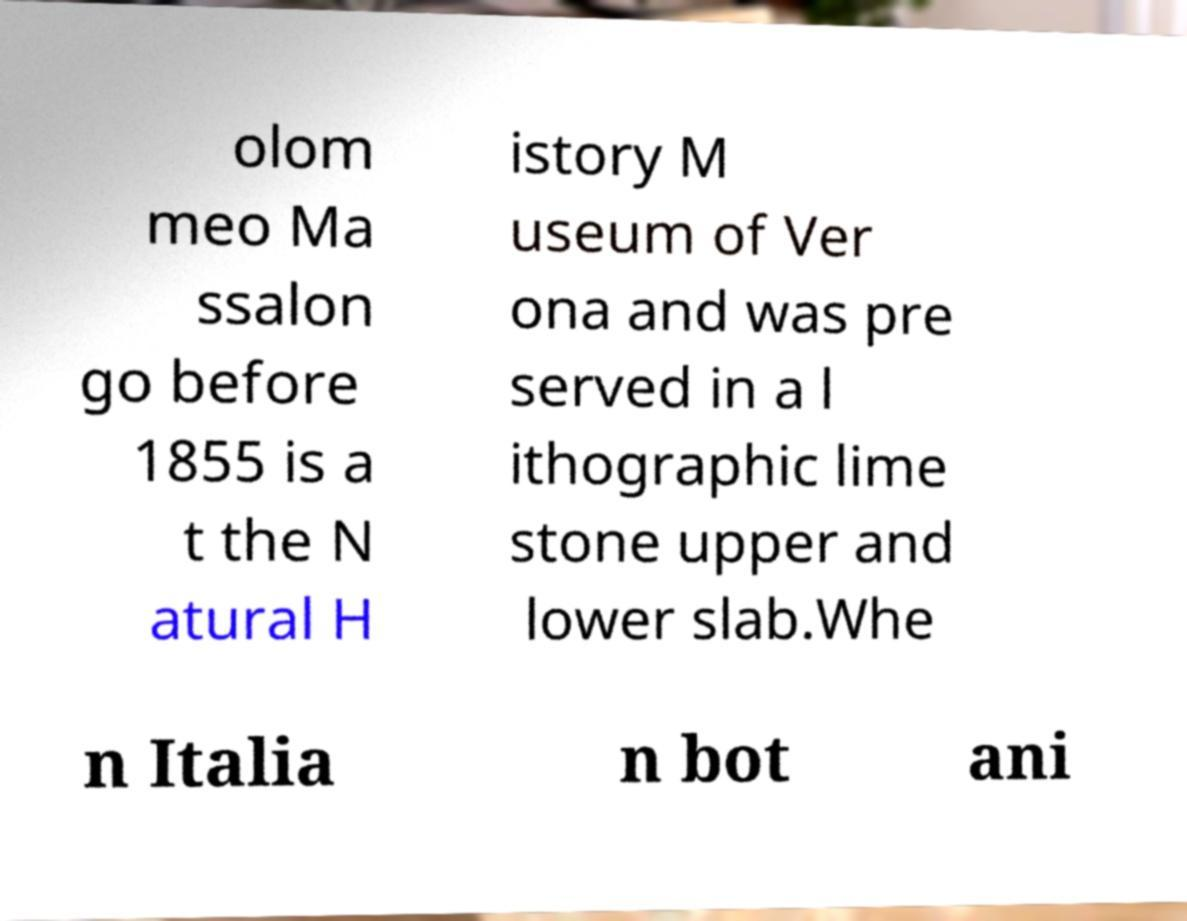Could you extract and type out the text from this image? olom meo Ma ssalon go before 1855 is a t the N atural H istory M useum of Ver ona and was pre served in a l ithographic lime stone upper and lower slab.Whe n Italia n bot ani 